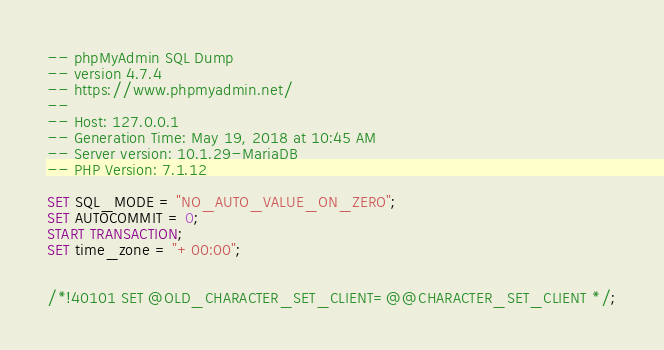<code> <loc_0><loc_0><loc_500><loc_500><_SQL_>-- phpMyAdmin SQL Dump
-- version 4.7.4
-- https://www.phpmyadmin.net/
--
-- Host: 127.0.0.1
-- Generation Time: May 19, 2018 at 10:45 AM
-- Server version: 10.1.29-MariaDB
-- PHP Version: 7.1.12

SET SQL_MODE = "NO_AUTO_VALUE_ON_ZERO";
SET AUTOCOMMIT = 0;
START TRANSACTION;
SET time_zone = "+00:00";


/*!40101 SET @OLD_CHARACTER_SET_CLIENT=@@CHARACTER_SET_CLIENT */;</code> 